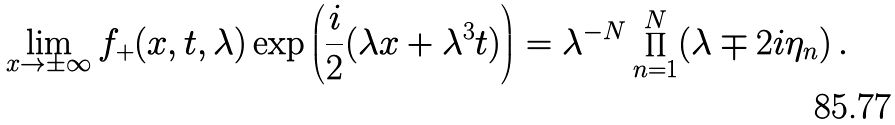<formula> <loc_0><loc_0><loc_500><loc_500>\lim _ { x \rightarrow \pm \infty } f _ { + } ( x , t , \lambda ) \exp \left ( \frac { i } { 2 } ( \lambda x + \lambda ^ { 3 } t ) \right ) = \lambda ^ { - N } \prod _ { n = 1 } ^ { N } ( \lambda \mp 2 i \eta _ { n } ) \, .</formula> 